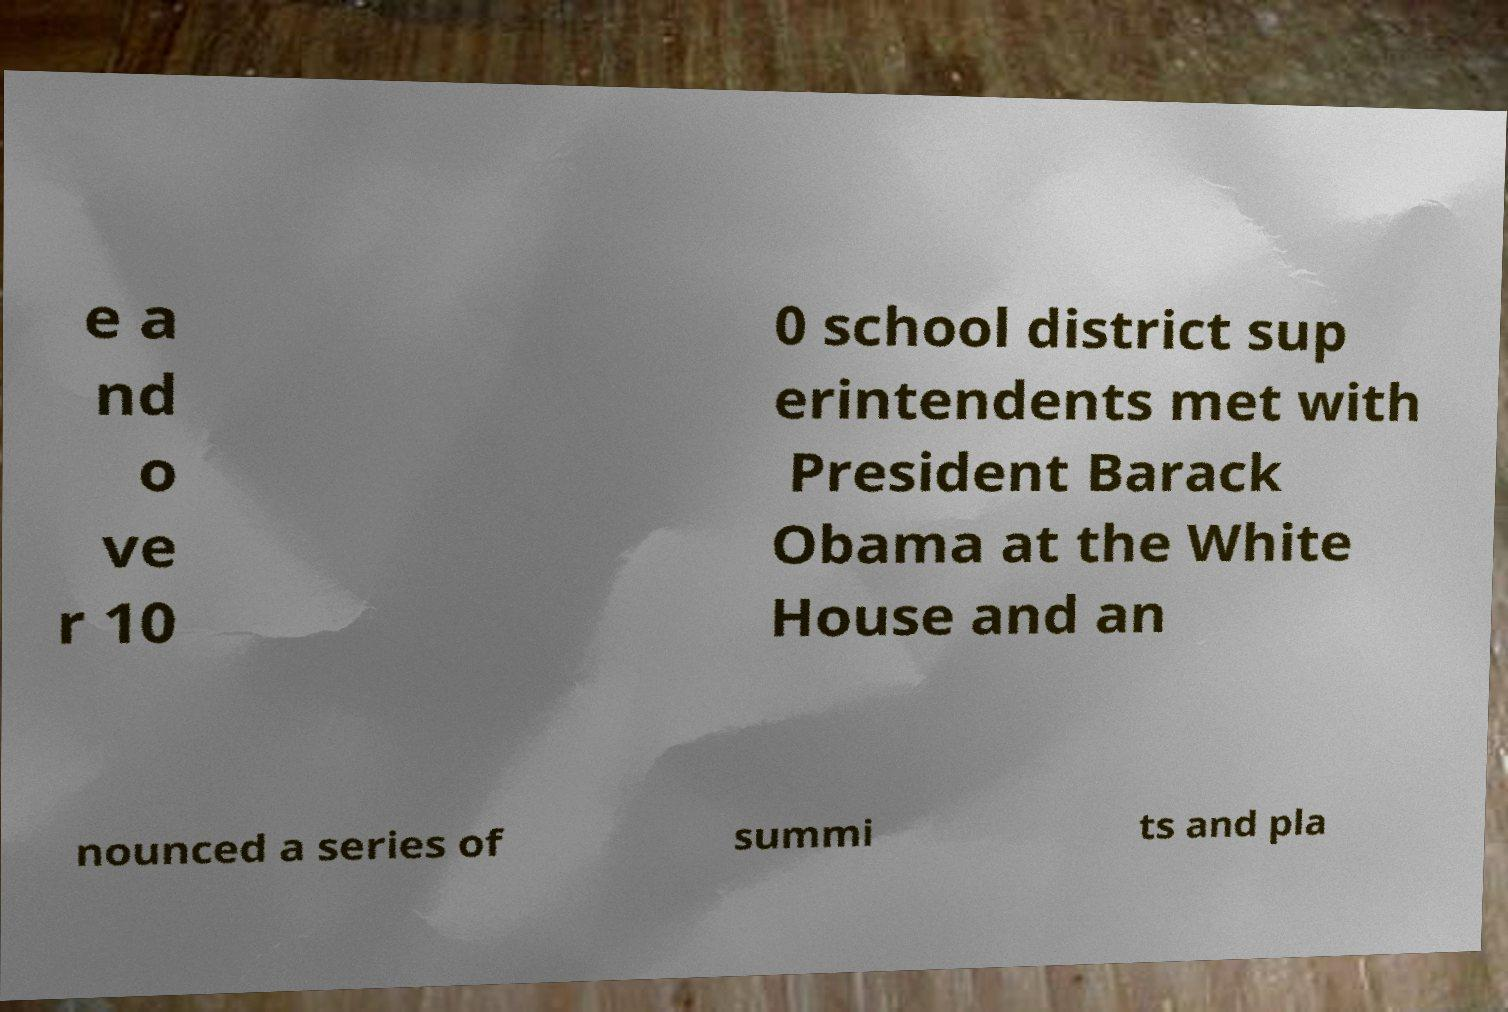What messages or text are displayed in this image? I need them in a readable, typed format. e a nd o ve r 10 0 school district sup erintendents met with President Barack Obama at the White House and an nounced a series of summi ts and pla 